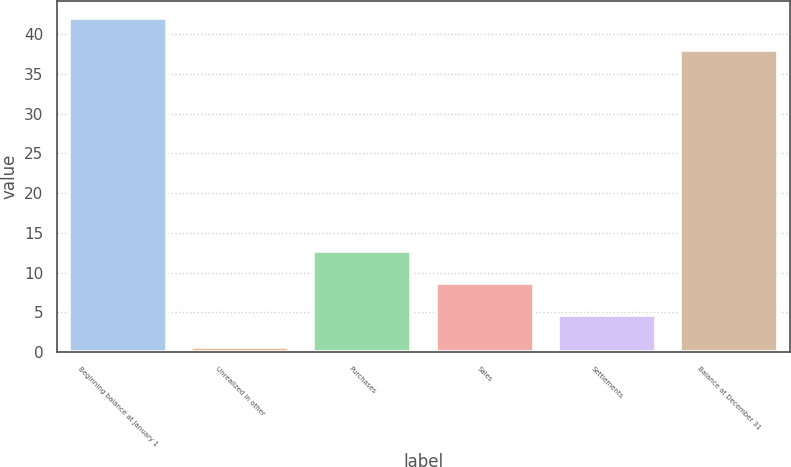Convert chart. <chart><loc_0><loc_0><loc_500><loc_500><bar_chart><fcel>Beginning balance at January 1<fcel>Unrealized in other<fcel>Purchases<fcel>Sales<fcel>Settlements<fcel>Balance at December 31<nl><fcel>42.03<fcel>0.66<fcel>12.75<fcel>8.72<fcel>4.69<fcel>38<nl></chart> 